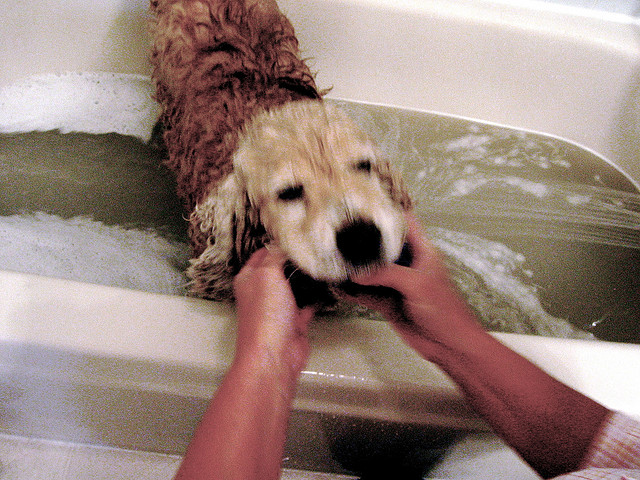<image>Does the animal in the picture have a name? It is unknown if the animal in the picture has a name or not. Does the animal in the picture have a name? I don't know if the animal in the picture has a name. However, it can have a name as 'dog'. 